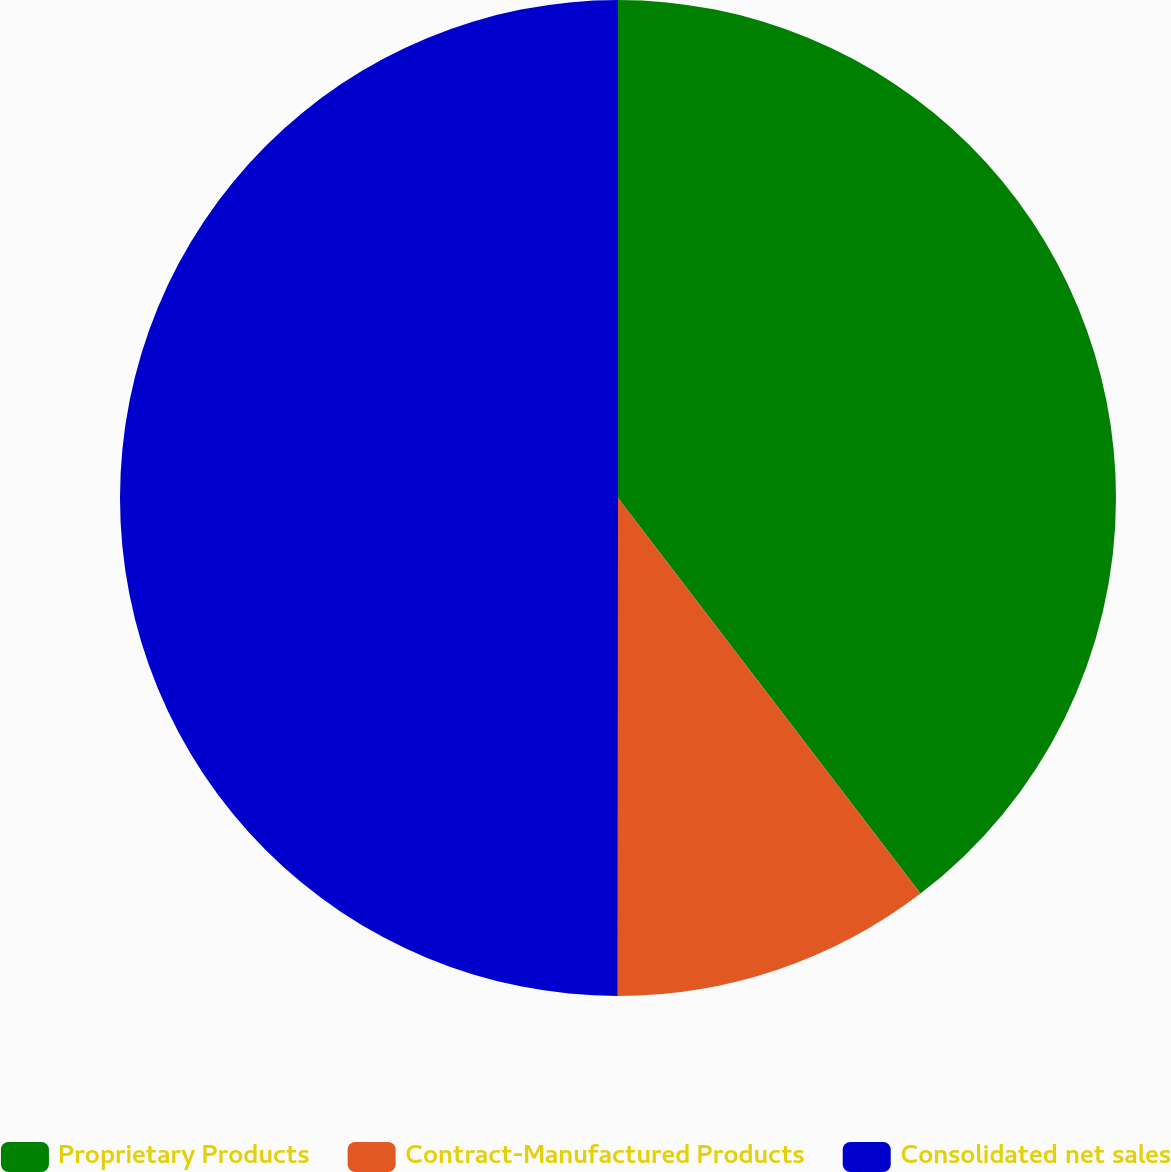Convert chart. <chart><loc_0><loc_0><loc_500><loc_500><pie_chart><fcel>Proprietary Products<fcel>Contract-Manufactured Products<fcel>Consolidated net sales<nl><fcel>39.61%<fcel>10.4%<fcel>49.99%<nl></chart> 